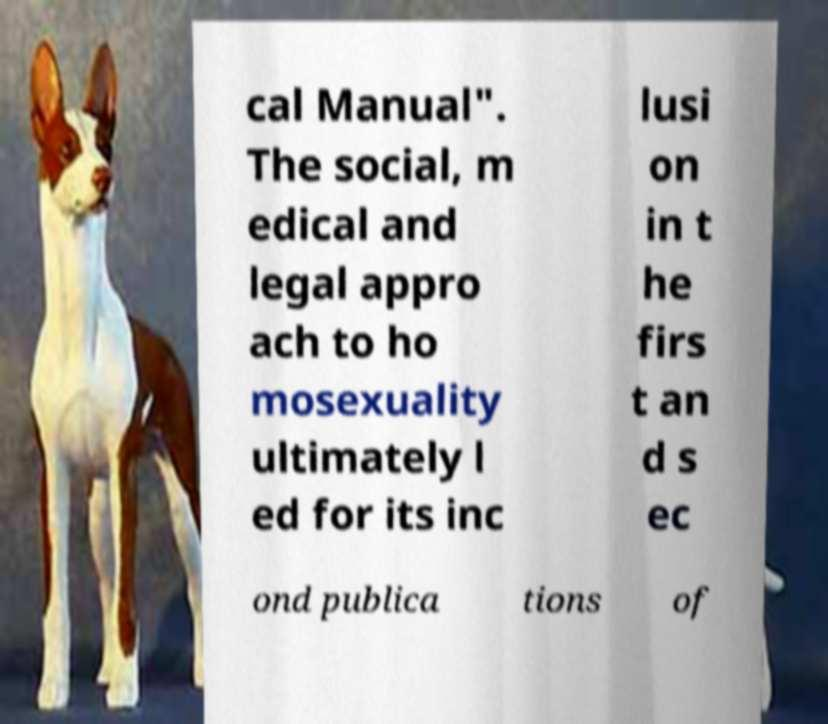Please identify and transcribe the text found in this image. cal Manual". The social, m edical and legal appro ach to ho mosexuality ultimately l ed for its inc lusi on in t he firs t an d s ec ond publica tions of 